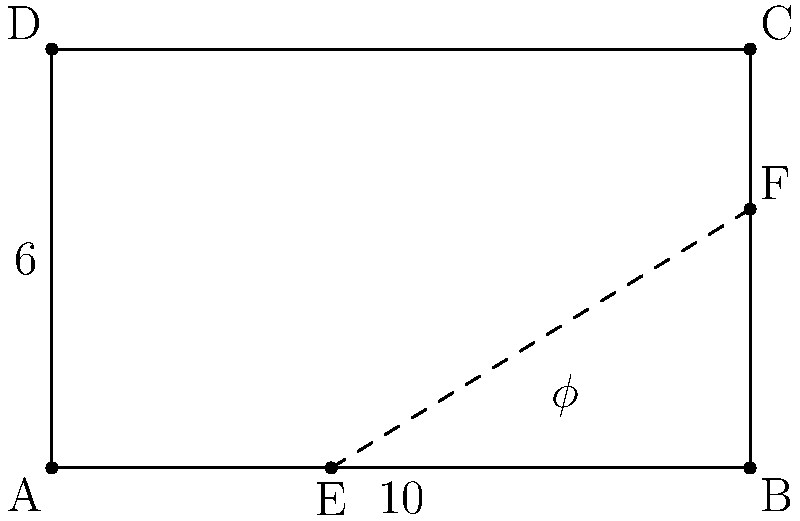In the facade design of a Baroque palace, the architect has incorporated the golden ratio ($\phi$) into the proportions. The facade is rectangular with a width of 10 meters and a height of 6 meters. A diagonal line is drawn from point E on the base to point F on the right side, dividing the facade according to the golden ratio. If point E is 4 meters from the left edge, what is the exact height of point F from the base? To solve this problem, we'll use the properties of the golden ratio and the given dimensions:

1) The golden ratio is defined as $\phi = \frac{1+\sqrt{5}}{2} \approx 1.618033989$

2) In a golden ratio division, the ratio of the whole to the larger part is equal to the ratio of the larger part to the smaller part.

3) Let's denote the height of F as x. Then, according to the golden ratio:
   $\frac{10}{6} = \frac{6}{x}$

4) Cross multiply:
   $10x = 36$

5) Solve for x:
   $x = \frac{36}{10} = 3.6$

6) To verify this is indeed the golden ratio, we can check:
   $\frac{6}{3.6} = \frac{10}{6} = \frac{5}{3} \approx 1.666667$

   This is very close to $\phi$, with the small difference due to rounding in our initial dimensions.

7) For more precision, we can use the exact value of $\phi$:
   $x = \frac{6}{\phi} = \frac{6}{\frac{1+\sqrt{5}}{2}} = \frac{12}{1+\sqrt{5}} = 3.708203932$

Therefore, the exact height of point F from the base is $\frac{12}{1+\sqrt{5}}$ meters, or approximately 3.708 meters.
Answer: $\frac{12}{1+\sqrt{5}}$ meters 